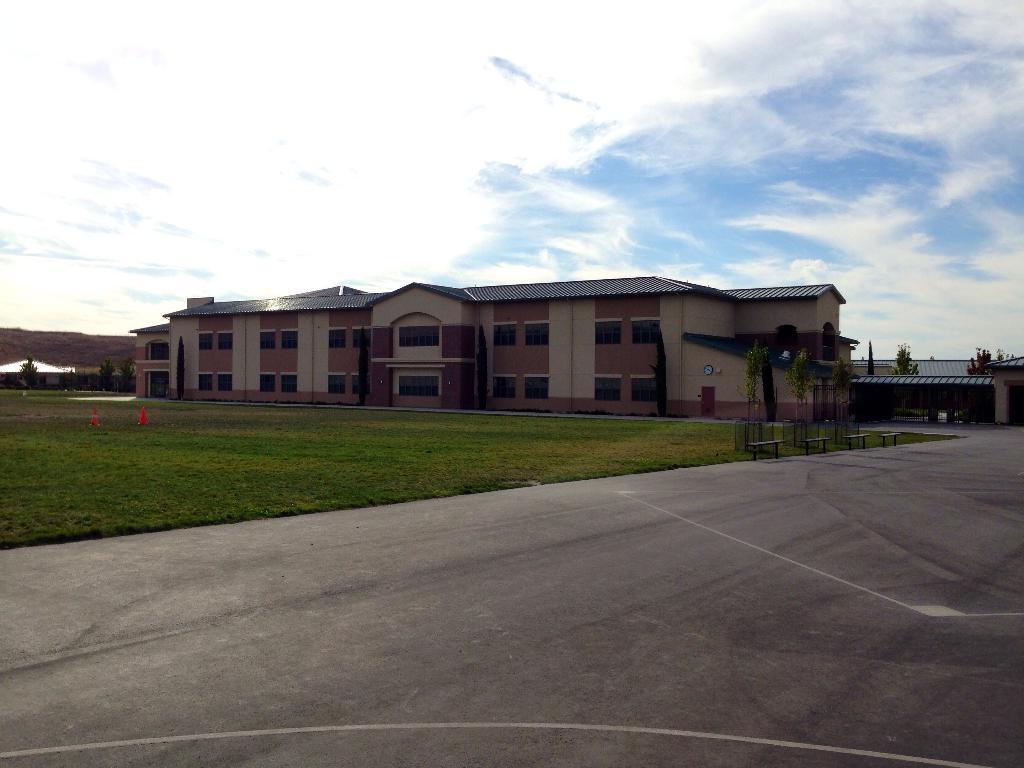Could you give a brief overview of what you see in this image? In this image we can see a building with windows. We can also see grass, plants, benches, traffic poles, the pathway and the sky which looks cloudy. 